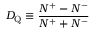Convert formula to latex. <formula><loc_0><loc_0><loc_500><loc_500>D _ { Q } \equiv \frac { N ^ { + } - N ^ { - } } { N ^ { + } + N ^ { - } }</formula> 